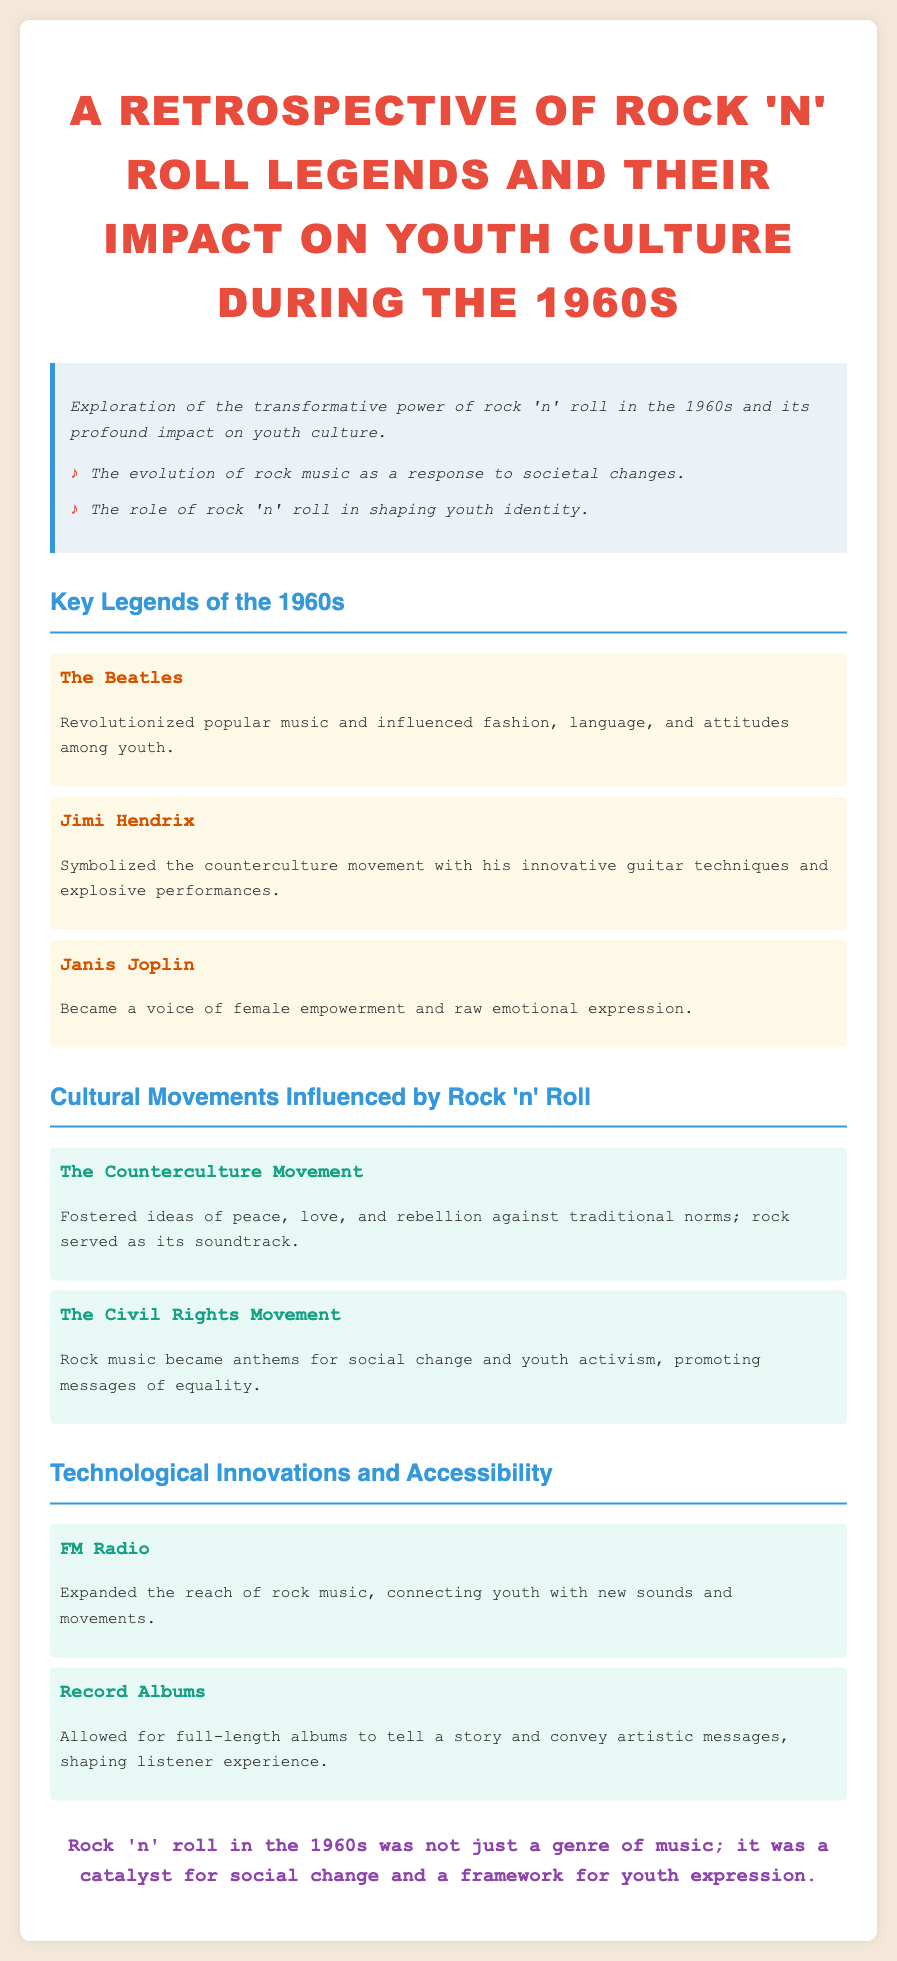what is the title of the document? The title is prominently displayed at the top of the document and describes its main focus on rock 'n' roll legends and youth culture in the 1960s.
Answer: A Retrospective of Rock 'n' Roll Legends and Their Impact on Youth Culture During the 1960s who is mentioned as a revolutionary band in the 1960s? This information can be found in the section detailing key legends, specifically highlighting The Beatles’ influence.
Answer: The Beatles what cultural movement is associated with Jimi Hendrix? The document connects Jimi Hendrix to the counterculture movement, illustrating his impact on that era.
Answer: Counterculture Movement how did rock music contribute to the Civil Rights Movement? The document states that rock music became anthems for social change and youth activism, promoting messages of equality, linking the genre to this historical movement.
Answer: Anthems for social change what technological innovation expanded the reach of rock music? The document highlights FM Radio as a significant innovation that connected youth with new sounds.
Answer: FM Radio what was the primary message of the counterculture movement? According to the document, the counterculture movement fostered ideas of peace, love, and rebellion against traditional norms.
Answer: Peace, love, and rebellion what type of expression did Janis Joplin represent? The document mentions Janis Joplin as a voice of female empowerment and raw emotional expression, indicating her significant role in that dimension.
Answer: Female empowerment what is indicated as a catalyst for social change in the 1960s? The conclusion of the document summarizes rock 'n' roll's role in facilitating social change and youth expression during that period.
Answer: Rock 'n' roll 